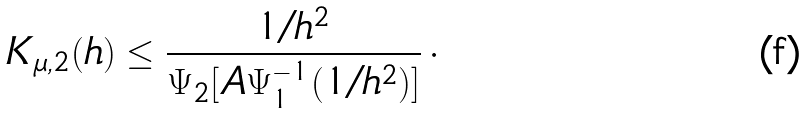Convert formula to latex. <formula><loc_0><loc_0><loc_500><loc_500>K _ { \mu , 2 } ( h ) \leq \frac { 1 / h ^ { 2 } } { \Psi _ { 2 } [ A \Psi _ { 1 } ^ { - 1 } ( 1 / h ^ { 2 } ) ] } \, \cdot</formula> 